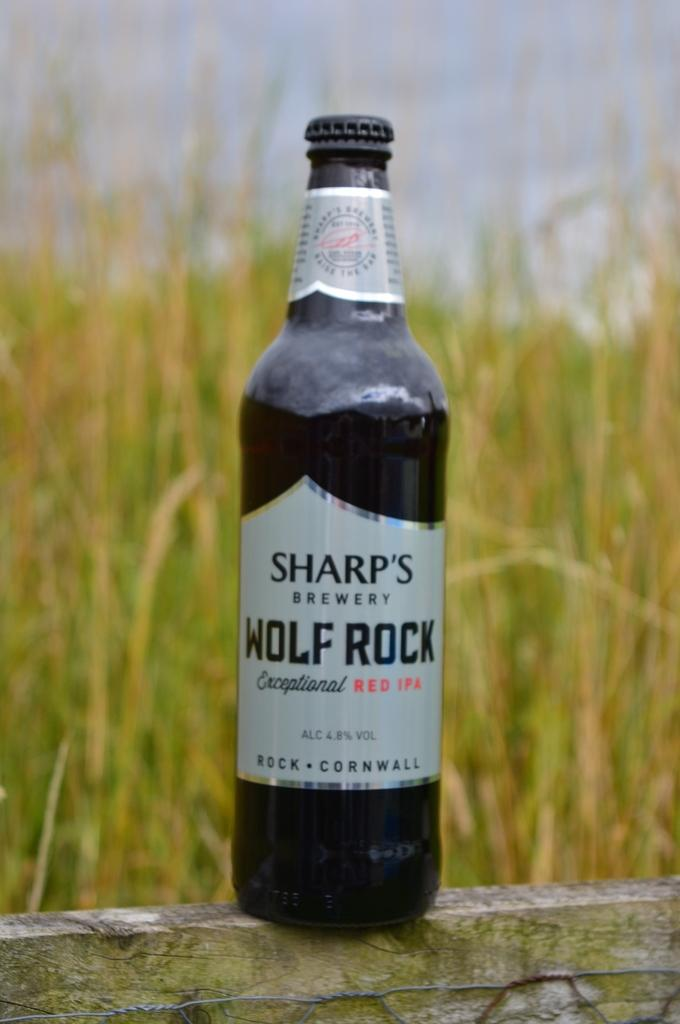<image>
Offer a succinct explanation of the picture presented. A bottle of Sharp's Brewery Wolf Rock IPA in front of a field. 